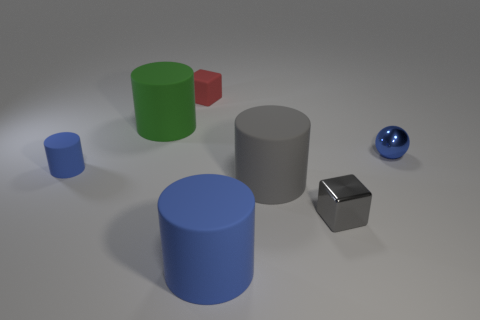Is there anything else that has the same color as the metal cube?
Make the answer very short. Yes. Is the number of blue rubber things to the left of the red rubber object less than the number of cyan metal things?
Give a very brief answer. No. What number of red blocks are there?
Ensure brevity in your answer.  1. There is a large blue object; is it the same shape as the large green thing behind the big gray matte thing?
Offer a very short reply. Yes. Is the number of tiny blue rubber things in front of the big gray cylinder less than the number of matte cubes that are in front of the gray shiny block?
Provide a short and direct response. No. Are there any other things that are the same shape as the tiny blue metal thing?
Offer a terse response. No. Does the small blue metal thing have the same shape as the big blue matte thing?
Your response must be concise. No. Is there anything else that has the same material as the large blue thing?
Give a very brief answer. Yes. The green cylinder has what size?
Give a very brief answer. Large. There is a rubber object that is in front of the red object and behind the small sphere; what color is it?
Make the answer very short. Green. 